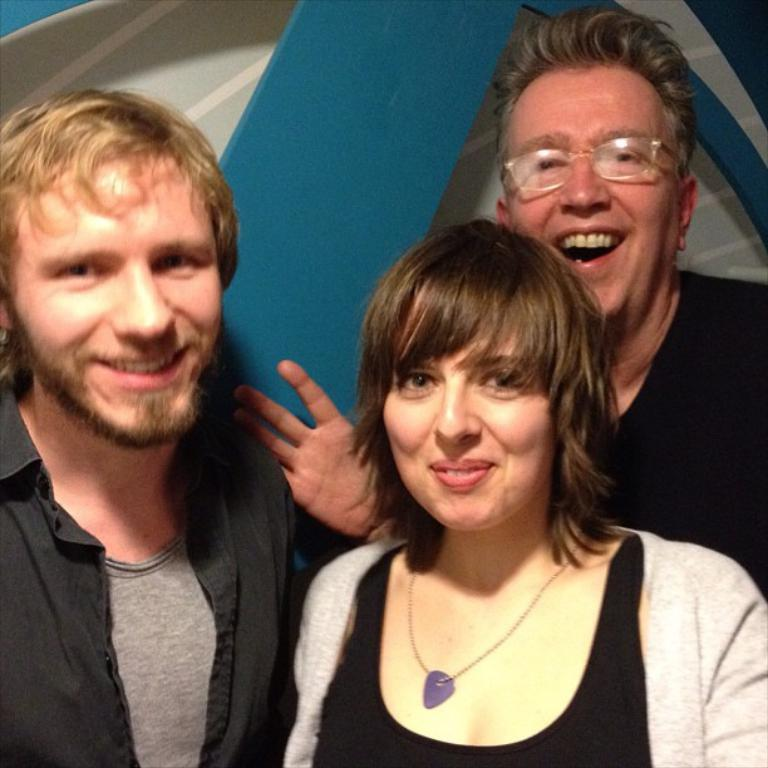How many people are in the image? There are two men and a woman in the image. What is the facial expression of the people in the image? The people in the image are smiling. What can be seen in the background of the image? There is a well in the background of the image. What type of scarf is the woman wearing in the image? There is no scarf visible in the image. What is the material of the stem in the image? There is no stem present in the image. 